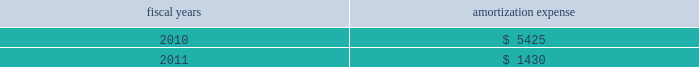Intangible assets are amortized on a straight-line basis over their estimated useful lives or on an accelerated method of amortization that is expected to reflect the estimated pattern of economic use .
The remaining amortization expense will be recognized over a weighted-average period of approximately 0.9 years .
Amortization expense from continuing operations , related to intangibles was $ 7.4 million , $ 9.3 million and $ 9.2 million in fiscal 2009 , 2008 and 2007 , respectively .
The company expects annual amortization expense for these intangible assets to be: .
Grant accounting certain of the company 2019s foreign subsidiaries have received various grants from governmental agencies .
These grants include capital , employment and research and development grants .
Capital grants for the acquisition of property and equipment are netted against the related capital expenditures and amortized as a credit to depreciation expense over the useful life of the related asset .
Employment grants , which relate to employee hiring and training , and research and development grants are recognized in earnings in the period in which the related expenditures are incurred by the company .
Translation of foreign currencies the functional currency for the company 2019s foreign sales and research and development operations is the applicable local currency .
Gains and losses resulting from translation of these foreign currencies into u.s .
Dollars are recorded in accumulated other comprehensive ( loss ) income .
Transaction gains and losses and remeasurement of foreign currency denominated assets and liabilities are included in income currently , including those at the company 2019s principal foreign manufacturing operations where the functional currency is the u.s .
Dollar .
Foreign currency transaction gains or losses included in other expenses , net , were not material in fiscal 2009 , 2008 or 2007 .
Derivative instruments and hedging agreements foreign exchange exposure management 2014 the company enters into forward foreign currency exchange contracts to offset certain operational and balance sheet exposures from the impact of changes in foreign currency exchange rates .
Such exposures result from the portion of the company 2019s operations , assets and liabilities that are denominated in currencies other than the u.s .
Dollar , primarily the euro ; other exposures include the philippine peso and the british pound .
These foreign currency exchange contracts are entered into to support transactions made in the normal course of business , and accordingly , are not speculative in nature .
The contracts are for periods consistent with the terms of the underlying transactions , generally one year or less .
Hedges related to anticipated transactions are designated and documented at the inception of the respective hedges as cash flow hedges and are evaluated for effectiveness monthly .
Derivative instruments are employed to eliminate or minimize certain foreign currency exposures that can be confidently identified and quantified .
As the terms of the contract and the underlying transaction are matched at inception , forward contract effectiveness is calculated by comparing the change in fair value of the contract to the change in the forward value of the anticipated transaction , with the effective portion of the gain or loss on the derivative instrument reported as a component of accumulated other comprehensive ( loss ) income ( oci ) in shareholders 2019 equity and reclassified into earnings in the same period during which the hedged transaction affects earnings .
Any residual change in fair value of the instruments , or ineffectiveness , is recognized immediately in other income/expense .
Additionally , the company enters into forward foreign currency contracts that economically hedge the gains and losses generated by the remeasurement of certain recorded assets and liabilities in a non-functional currency .
Changes in the fair value of these undesignated hedges are recognized in other income/expense immediately as an offset to the changes in the fair value of the asset or liability being hedged .
Analog devices , inc .
Notes to consolidated financial statements 2014 ( continued ) .
What is the growth rate in amortization expense in 2009? 
Computations: ((7.4 - 9.3) / 9.3)
Answer: -0.2043. 